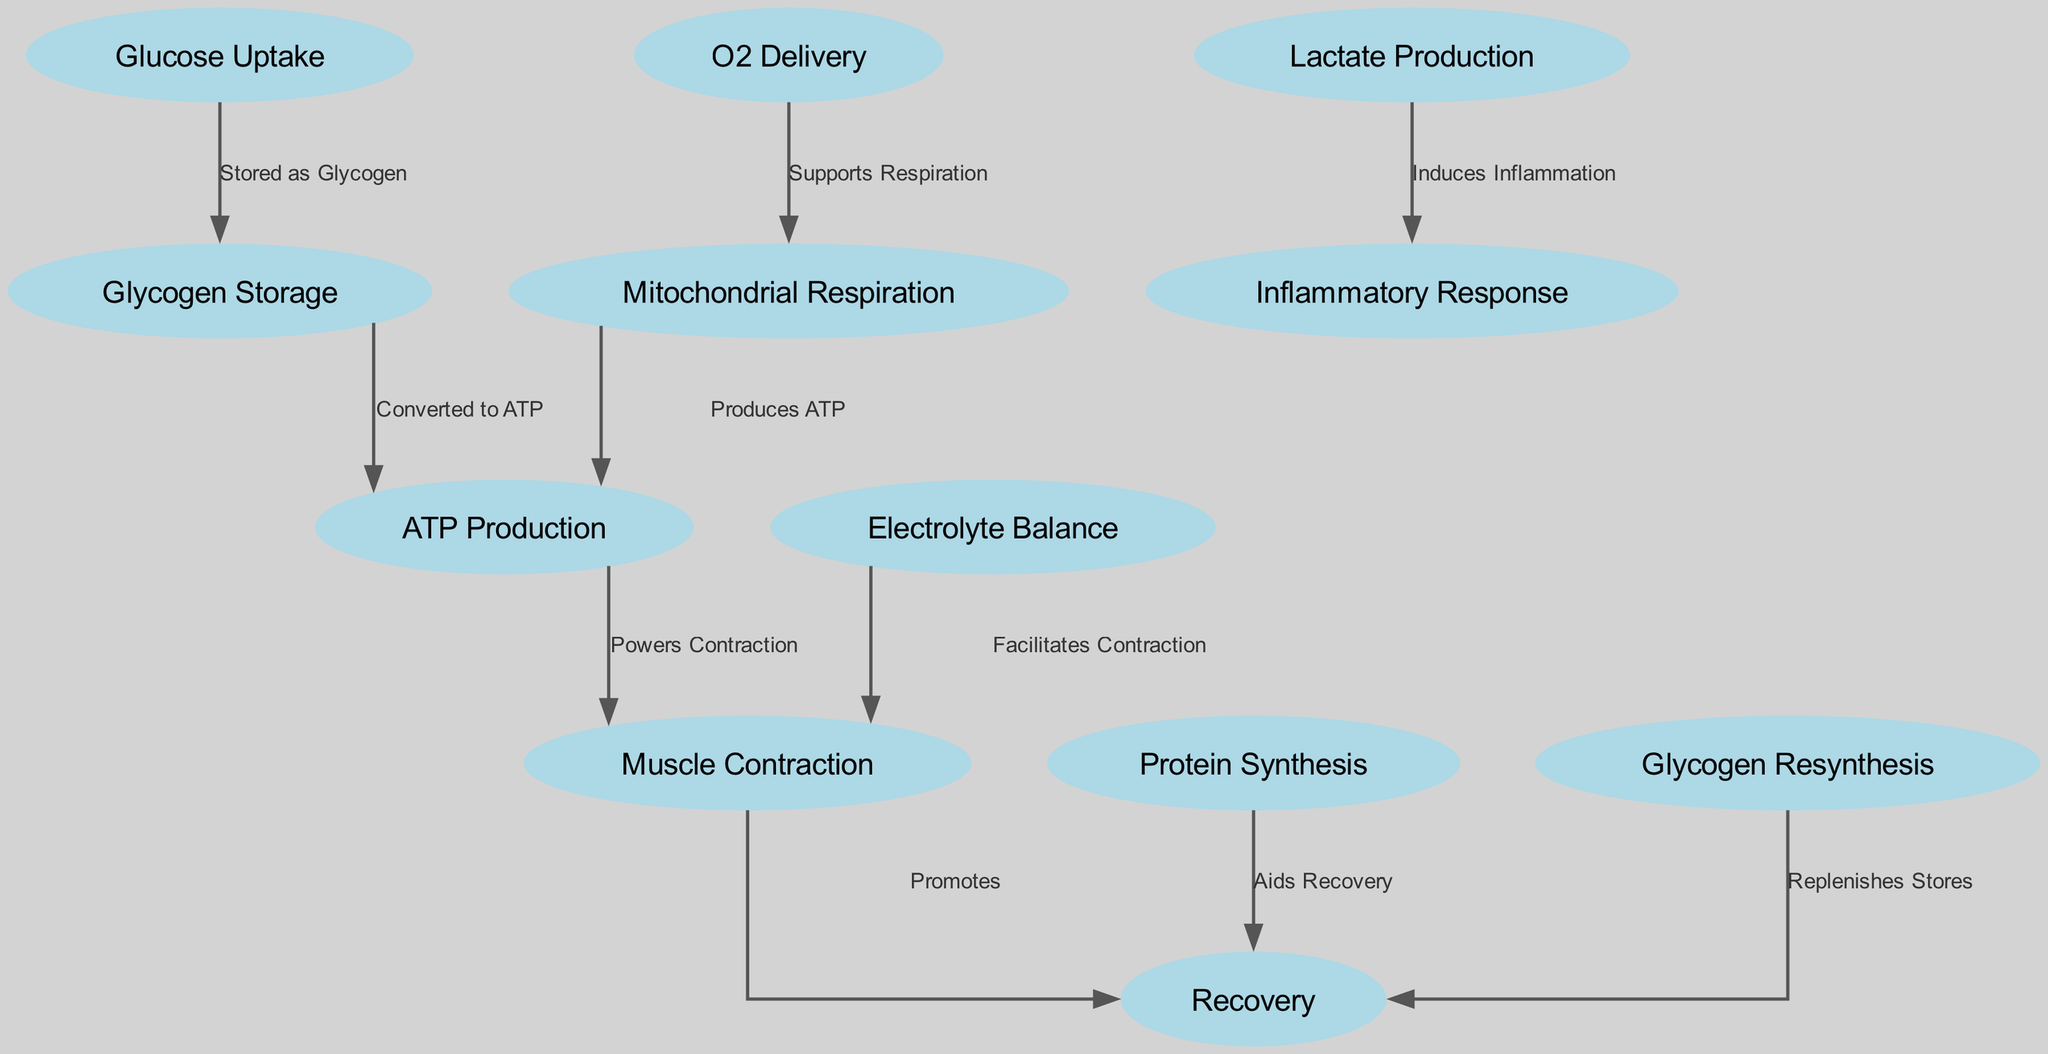What nodes are involved in ATP Production? The diagram shows that Glycogen Storage converts to ATP Production and Mitochondrial Respiration also produces ATP. Therefore, the nodes Glucose Uptake, Glycogen Storage, and Mitochondrial Respiration are involved.
Answer: Glycogen Storage, Mitochondrial Respiration What is produced from Lactate Production? According to the diagram, the edge from Lactate Production leads to Inflammatory Response and is labeled "Induces Inflammation," indicating that inflammation is produced as a result.
Answer: Inflammation How many total nodes are represented in the diagram? Counting the nodes listed in the diagram's data, there are twelve nodes: Glucose Uptake, Glycogen Storage, ATP Production, Lactate Production, O2 Delivery, Mitochondrial Respiration, Electrolyte Balance, Muscle Contraction, Protein Synthesis, Inflammatory Response, Glycogen Resynthesis, Recovery. Thus, the total is twelve.
Answer: Twelve What role does O2 Delivery play in ATP Production? The diagram indicates that O2 Delivery supports Mitochondrial Respiration, which in turn produces ATP. Therefore, O2 Delivery indirectly facilitates ATP Production through its support of Mitochondrial Respiration.
Answer: Supports Mitochondrial Respiration Which two nodes directly lead to Recovery? In the diagram, Muscle Contraction and Protein Synthesis both have edges that lead directly to the Recovery node. Thus, these two nodes are involved in the recovery phase.
Answer: Muscle Contraction, Protein Synthesis What effect does Electrolyte Balance have on Muscle Contraction? The edge in the diagram shows that Electrolyte Balance facilitates Muscle Contraction, indicating that maintaining electrolyte levels is crucial for effective contraction of the muscles.
Answer: Facilitates Contraction What process replenishes stores during the Recovery phase? The diagram indicates that Glycogen Resynthesis has an edge leading to Recovery, implying that this process is responsible for replenishing energy stores during recovery.
Answer: Glycogen Resynthesis How is ATP involved in Muscle Contraction? The diagram displays that ATP Production powers Muscle Contraction, indicating that ATP is essential for muscle contraction to occur.
Answer: Powers Contraction 